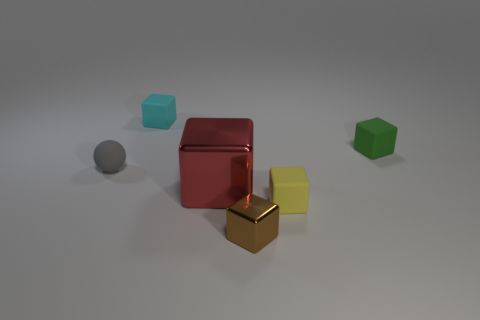Subtract all cyan rubber cubes. How many cubes are left? 4 Subtract all brown cubes. How many cubes are left? 4 Add 1 gray rubber things. How many objects exist? 7 Add 2 tiny rubber objects. How many tiny rubber objects exist? 6 Subtract 1 green blocks. How many objects are left? 5 Subtract all blocks. How many objects are left? 1 Subtract 1 spheres. How many spheres are left? 0 Subtract all cyan cubes. Subtract all purple balls. How many cubes are left? 4 Subtract all blue cylinders. How many purple blocks are left? 0 Subtract all cyan blocks. Subtract all cyan matte objects. How many objects are left? 4 